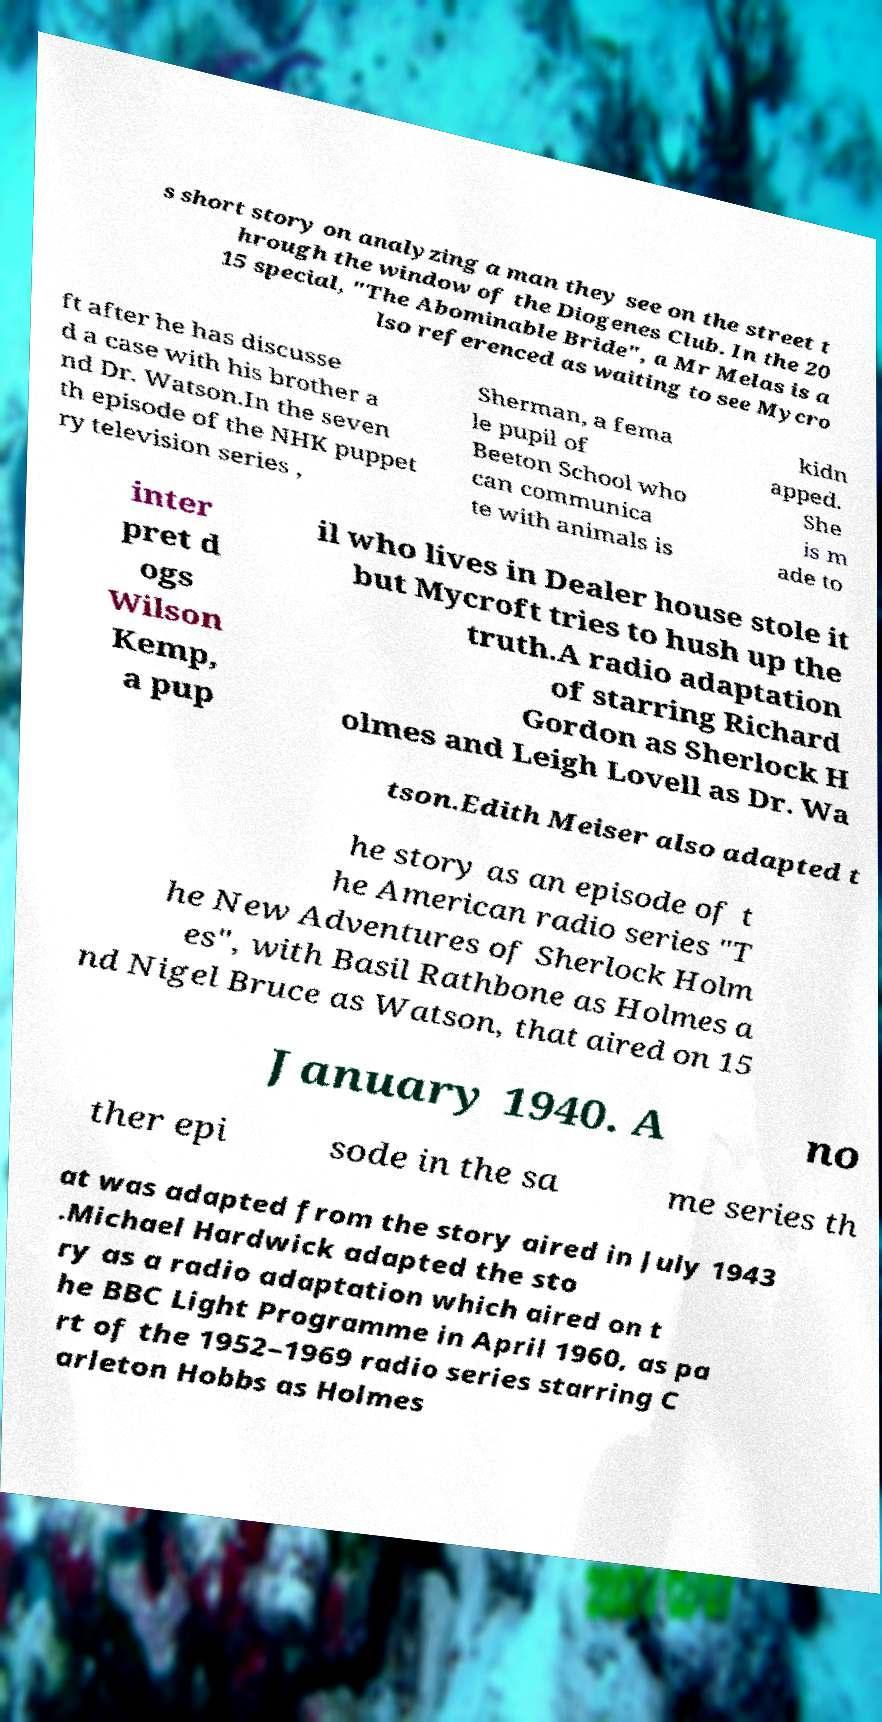Could you assist in decoding the text presented in this image and type it out clearly? s short story on analyzing a man they see on the street t hrough the window of the Diogenes Club. In the 20 15 special, "The Abominable Bride", a Mr Melas is a lso referenced as waiting to see Mycro ft after he has discusse d a case with his brother a nd Dr. Watson.In the seven th episode of the NHK puppet ry television series , Sherman, a fema le pupil of Beeton School who can communica te with animals is kidn apped. She is m ade to inter pret d ogs Wilson Kemp, a pup il who lives in Dealer house stole it but Mycroft tries to hush up the truth.A radio adaptation of starring Richard Gordon as Sherlock H olmes and Leigh Lovell as Dr. Wa tson.Edith Meiser also adapted t he story as an episode of t he American radio series "T he New Adventures of Sherlock Holm es", with Basil Rathbone as Holmes a nd Nigel Bruce as Watson, that aired on 15 January 1940. A no ther epi sode in the sa me series th at was adapted from the story aired in July 1943 .Michael Hardwick adapted the sto ry as a radio adaptation which aired on t he BBC Light Programme in April 1960, as pa rt of the 1952–1969 radio series starring C arleton Hobbs as Holmes 